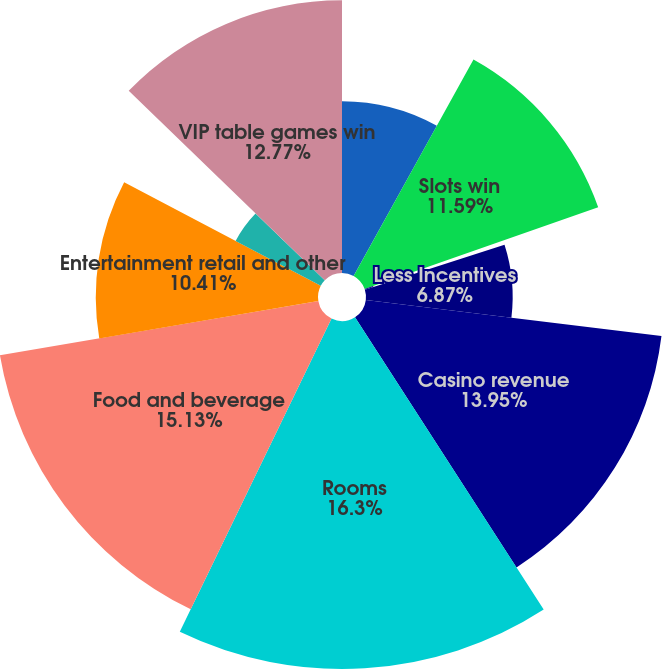Convert chart to OTSL. <chart><loc_0><loc_0><loc_500><loc_500><pie_chart><fcel>Table games win<fcel>Slots win<fcel>Other<fcel>Less Incentives<fcel>Casino revenue<fcel>Rooms<fcel>Food and beverage<fcel>Entertainment retail and other<fcel>Non-casino revenue<fcel>VIP table games win<nl><fcel>8.05%<fcel>11.59%<fcel>0.42%<fcel>6.87%<fcel>13.95%<fcel>16.3%<fcel>15.13%<fcel>10.41%<fcel>4.51%<fcel>12.77%<nl></chart> 